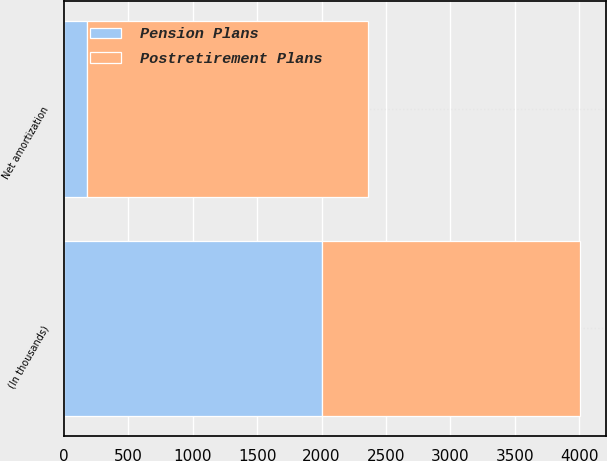Convert chart to OTSL. <chart><loc_0><loc_0><loc_500><loc_500><stacked_bar_chart><ecel><fcel>(In thousands)<fcel>Net amortization<nl><fcel>Postretirement Plans<fcel>2005<fcel>2186<nl><fcel>Pension Plans<fcel>2005<fcel>175<nl></chart> 